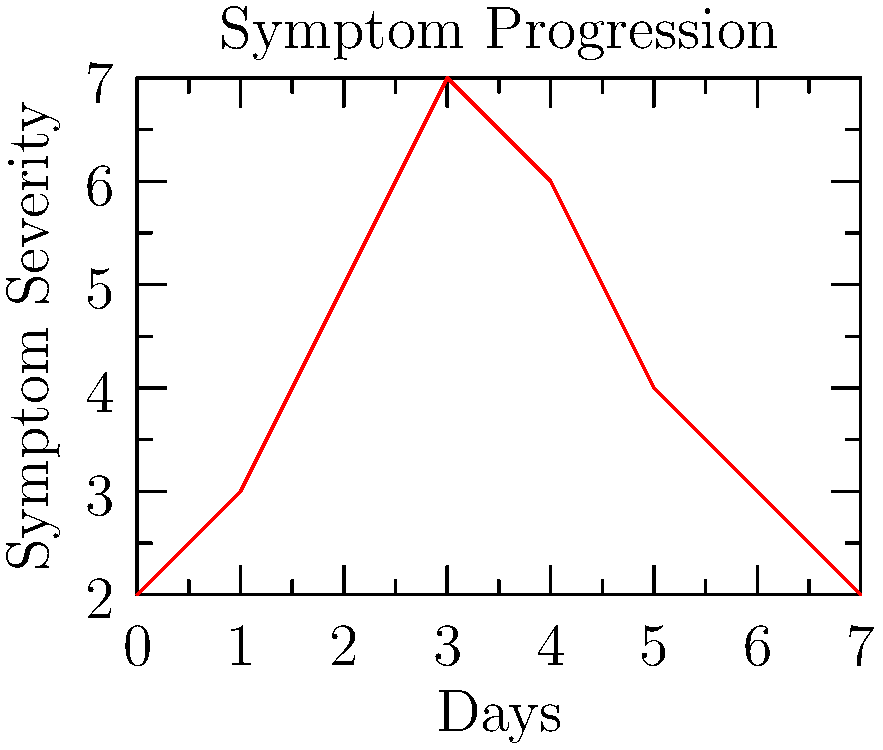A retired physician has been treating your symptoms for a week. The graph shows the severity of your symptoms over 7 days. On which day did your symptoms peak, and how many days did it take for the severity to return to its initial level? To answer this question, we need to analyze the graph carefully:

1. Identify the peak:
   - Look for the highest point on the graph
   - The peak occurs on day 3, with a severity of 7

2. Find when severity returns to initial level:
   - Initial severity on day 0 is 2
   - Follow the line from the peak downwards
   - The severity returns to 2 on day 7

3. Calculate days from peak to return to initial level:
   - Peak day: 3
   - Return to initial level: day 7
   - Days between: $7 - 3 = 4$ days

Therefore, the symptoms peaked on day 3, and it took 4 days for the severity to return to its initial level.
Answer: Day 3; 4 days 